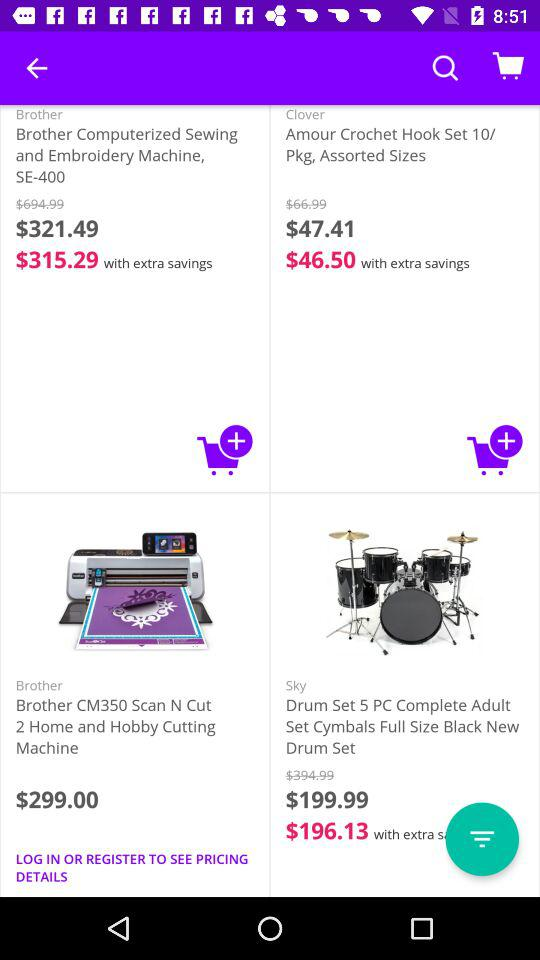What is the name of the application? The name of the application is "Jet". 